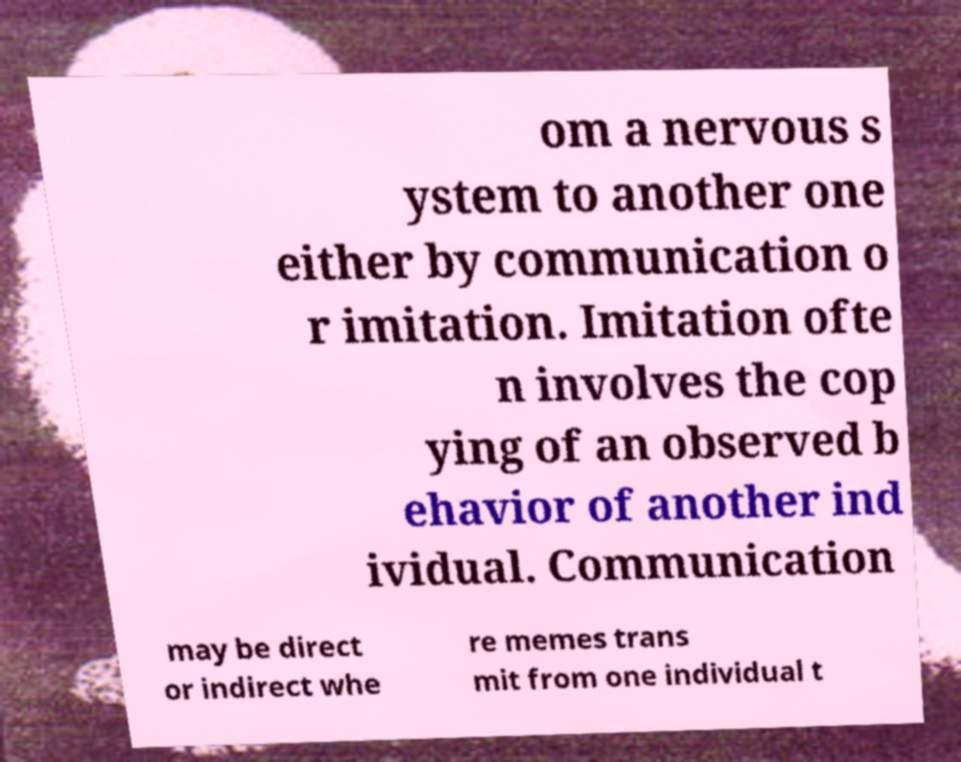Please identify and transcribe the text found in this image. om a nervous s ystem to another one either by communication o r imitation. Imitation ofte n involves the cop ying of an observed b ehavior of another ind ividual. Communication may be direct or indirect whe re memes trans mit from one individual t 